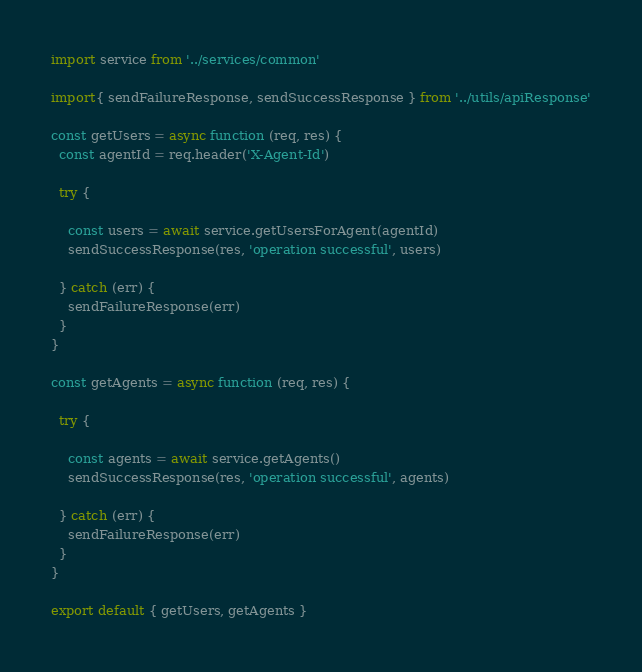Convert code to text. <code><loc_0><loc_0><loc_500><loc_500><_JavaScript_>import service from '../services/common'

import{ sendFailureResponse, sendSuccessResponse } from '../utils/apiResponse'

const getUsers = async function (req, res) {
  const agentId = req.header('X-Agent-Id')

  try {

    const users = await service.getUsersForAgent(agentId)
    sendSuccessResponse(res, 'operation successful', users)

  } catch (err) {
    sendFailureResponse(err)
  }
}

const getAgents = async function (req, res) {

  try {

    const agents = await service.getAgents()
    sendSuccessResponse(res, 'operation successful', agents)

  } catch (err) {
    sendFailureResponse(err)
  }
}

export default { getUsers, getAgents }
</code> 